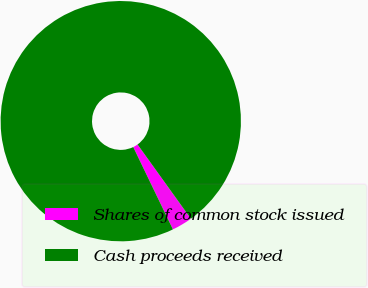<chart> <loc_0><loc_0><loc_500><loc_500><pie_chart><fcel>Shares of common stock issued<fcel>Cash proceeds received<nl><fcel>2.77%<fcel>97.23%<nl></chart> 